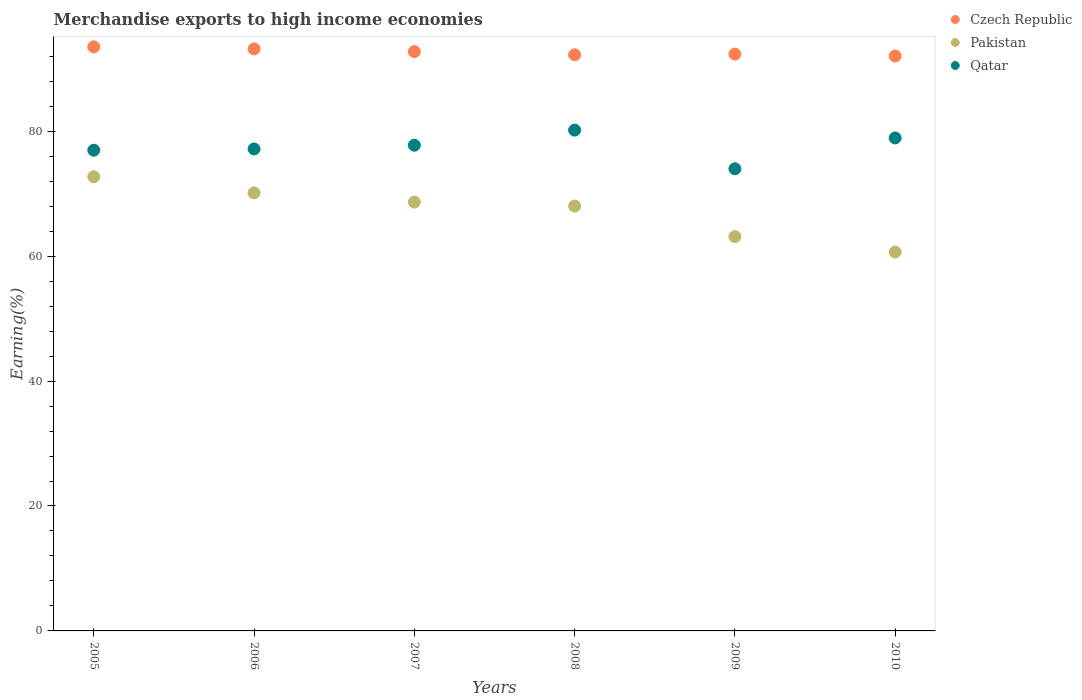Is the number of dotlines equal to the number of legend labels?
Offer a terse response. Yes. What is the percentage of amount earned from merchandise exports in Qatar in 2009?
Make the answer very short. 73.98. Across all years, what is the maximum percentage of amount earned from merchandise exports in Pakistan?
Your answer should be very brief. 72.71. Across all years, what is the minimum percentage of amount earned from merchandise exports in Czech Republic?
Provide a short and direct response. 92.03. What is the total percentage of amount earned from merchandise exports in Pakistan in the graph?
Provide a succinct answer. 403.28. What is the difference between the percentage of amount earned from merchandise exports in Pakistan in 2008 and that in 2009?
Make the answer very short. 4.9. What is the difference between the percentage of amount earned from merchandise exports in Czech Republic in 2009 and the percentage of amount earned from merchandise exports in Pakistan in 2008?
Keep it short and to the point. 24.32. What is the average percentage of amount earned from merchandise exports in Czech Republic per year?
Your answer should be very brief. 92.67. In the year 2005, what is the difference between the percentage of amount earned from merchandise exports in Qatar and percentage of amount earned from merchandise exports in Pakistan?
Offer a very short reply. 4.25. What is the ratio of the percentage of amount earned from merchandise exports in Pakistan in 2005 to that in 2010?
Ensure brevity in your answer.  1.2. What is the difference between the highest and the second highest percentage of amount earned from merchandise exports in Pakistan?
Give a very brief answer. 2.58. What is the difference between the highest and the lowest percentage of amount earned from merchandise exports in Pakistan?
Your response must be concise. 12.05. Is the percentage of amount earned from merchandise exports in Czech Republic strictly greater than the percentage of amount earned from merchandise exports in Qatar over the years?
Your answer should be compact. Yes. Is the percentage of amount earned from merchandise exports in Czech Republic strictly less than the percentage of amount earned from merchandise exports in Qatar over the years?
Keep it short and to the point. No. How many years are there in the graph?
Offer a very short reply. 6. Are the values on the major ticks of Y-axis written in scientific E-notation?
Your answer should be compact. No. How many legend labels are there?
Offer a very short reply. 3. What is the title of the graph?
Make the answer very short. Merchandise exports to high income economies. What is the label or title of the Y-axis?
Keep it short and to the point. Earning(%). What is the Earning(%) of Czech Republic in 2005?
Give a very brief answer. 93.51. What is the Earning(%) of Pakistan in 2005?
Offer a very short reply. 72.71. What is the Earning(%) in Qatar in 2005?
Offer a terse response. 76.96. What is the Earning(%) in Czech Republic in 2006?
Offer a terse response. 93.18. What is the Earning(%) of Pakistan in 2006?
Provide a succinct answer. 70.13. What is the Earning(%) of Qatar in 2006?
Provide a short and direct response. 77.16. What is the Earning(%) of Czech Republic in 2007?
Provide a succinct answer. 92.75. What is the Earning(%) of Pakistan in 2007?
Your answer should be compact. 68.65. What is the Earning(%) of Qatar in 2007?
Provide a succinct answer. 77.75. What is the Earning(%) of Czech Republic in 2008?
Your response must be concise. 92.23. What is the Earning(%) of Pakistan in 2008?
Provide a succinct answer. 68.02. What is the Earning(%) of Qatar in 2008?
Offer a very short reply. 80.17. What is the Earning(%) in Czech Republic in 2009?
Give a very brief answer. 92.34. What is the Earning(%) of Pakistan in 2009?
Give a very brief answer. 63.12. What is the Earning(%) in Qatar in 2009?
Make the answer very short. 73.98. What is the Earning(%) of Czech Republic in 2010?
Offer a very short reply. 92.03. What is the Earning(%) in Pakistan in 2010?
Make the answer very short. 60.66. What is the Earning(%) in Qatar in 2010?
Your answer should be very brief. 78.92. Across all years, what is the maximum Earning(%) in Czech Republic?
Your response must be concise. 93.51. Across all years, what is the maximum Earning(%) in Pakistan?
Offer a terse response. 72.71. Across all years, what is the maximum Earning(%) of Qatar?
Your answer should be compact. 80.17. Across all years, what is the minimum Earning(%) in Czech Republic?
Make the answer very short. 92.03. Across all years, what is the minimum Earning(%) of Pakistan?
Provide a short and direct response. 60.66. Across all years, what is the minimum Earning(%) of Qatar?
Provide a short and direct response. 73.98. What is the total Earning(%) in Czech Republic in the graph?
Give a very brief answer. 556.04. What is the total Earning(%) of Pakistan in the graph?
Your response must be concise. 403.28. What is the total Earning(%) in Qatar in the graph?
Make the answer very short. 464.95. What is the difference between the Earning(%) of Czech Republic in 2005 and that in 2006?
Your answer should be very brief. 0.33. What is the difference between the Earning(%) in Pakistan in 2005 and that in 2006?
Your response must be concise. 2.58. What is the difference between the Earning(%) of Qatar in 2005 and that in 2006?
Offer a very short reply. -0.2. What is the difference between the Earning(%) of Czech Republic in 2005 and that in 2007?
Make the answer very short. 0.76. What is the difference between the Earning(%) in Pakistan in 2005 and that in 2007?
Keep it short and to the point. 4.06. What is the difference between the Earning(%) of Qatar in 2005 and that in 2007?
Offer a very short reply. -0.8. What is the difference between the Earning(%) of Czech Republic in 2005 and that in 2008?
Offer a terse response. 1.27. What is the difference between the Earning(%) in Pakistan in 2005 and that in 2008?
Offer a very short reply. 4.69. What is the difference between the Earning(%) in Qatar in 2005 and that in 2008?
Your answer should be very brief. -3.22. What is the difference between the Earning(%) of Czech Republic in 2005 and that in 2009?
Provide a short and direct response. 1.17. What is the difference between the Earning(%) of Pakistan in 2005 and that in 2009?
Your response must be concise. 9.59. What is the difference between the Earning(%) in Qatar in 2005 and that in 2009?
Your answer should be very brief. 2.97. What is the difference between the Earning(%) of Czech Republic in 2005 and that in 2010?
Your answer should be compact. 1.48. What is the difference between the Earning(%) in Pakistan in 2005 and that in 2010?
Offer a terse response. 12.05. What is the difference between the Earning(%) in Qatar in 2005 and that in 2010?
Provide a succinct answer. -1.96. What is the difference between the Earning(%) in Czech Republic in 2006 and that in 2007?
Offer a terse response. 0.43. What is the difference between the Earning(%) in Pakistan in 2006 and that in 2007?
Provide a short and direct response. 1.48. What is the difference between the Earning(%) in Qatar in 2006 and that in 2007?
Ensure brevity in your answer.  -0.6. What is the difference between the Earning(%) in Czech Republic in 2006 and that in 2008?
Make the answer very short. 0.95. What is the difference between the Earning(%) in Pakistan in 2006 and that in 2008?
Make the answer very short. 2.11. What is the difference between the Earning(%) of Qatar in 2006 and that in 2008?
Give a very brief answer. -3.02. What is the difference between the Earning(%) of Czech Republic in 2006 and that in 2009?
Provide a succinct answer. 0.84. What is the difference between the Earning(%) in Pakistan in 2006 and that in 2009?
Keep it short and to the point. 7.01. What is the difference between the Earning(%) of Qatar in 2006 and that in 2009?
Give a very brief answer. 3.17. What is the difference between the Earning(%) in Czech Republic in 2006 and that in 2010?
Your response must be concise. 1.15. What is the difference between the Earning(%) of Pakistan in 2006 and that in 2010?
Make the answer very short. 9.47. What is the difference between the Earning(%) of Qatar in 2006 and that in 2010?
Offer a terse response. -1.76. What is the difference between the Earning(%) of Czech Republic in 2007 and that in 2008?
Provide a succinct answer. 0.51. What is the difference between the Earning(%) of Pakistan in 2007 and that in 2008?
Give a very brief answer. 0.63. What is the difference between the Earning(%) of Qatar in 2007 and that in 2008?
Give a very brief answer. -2.42. What is the difference between the Earning(%) of Czech Republic in 2007 and that in 2009?
Give a very brief answer. 0.4. What is the difference between the Earning(%) in Pakistan in 2007 and that in 2009?
Your answer should be very brief. 5.53. What is the difference between the Earning(%) of Qatar in 2007 and that in 2009?
Your response must be concise. 3.77. What is the difference between the Earning(%) of Czech Republic in 2007 and that in 2010?
Offer a very short reply. 0.71. What is the difference between the Earning(%) in Pakistan in 2007 and that in 2010?
Ensure brevity in your answer.  7.99. What is the difference between the Earning(%) in Qatar in 2007 and that in 2010?
Your response must be concise. -1.17. What is the difference between the Earning(%) in Czech Republic in 2008 and that in 2009?
Provide a short and direct response. -0.11. What is the difference between the Earning(%) in Pakistan in 2008 and that in 2009?
Provide a short and direct response. 4.9. What is the difference between the Earning(%) in Qatar in 2008 and that in 2009?
Provide a short and direct response. 6.19. What is the difference between the Earning(%) in Czech Republic in 2008 and that in 2010?
Ensure brevity in your answer.  0.2. What is the difference between the Earning(%) of Pakistan in 2008 and that in 2010?
Offer a terse response. 7.36. What is the difference between the Earning(%) in Qatar in 2008 and that in 2010?
Provide a succinct answer. 1.25. What is the difference between the Earning(%) of Czech Republic in 2009 and that in 2010?
Make the answer very short. 0.31. What is the difference between the Earning(%) in Pakistan in 2009 and that in 2010?
Provide a short and direct response. 2.47. What is the difference between the Earning(%) in Qatar in 2009 and that in 2010?
Give a very brief answer. -4.94. What is the difference between the Earning(%) of Czech Republic in 2005 and the Earning(%) of Pakistan in 2006?
Offer a very short reply. 23.38. What is the difference between the Earning(%) in Czech Republic in 2005 and the Earning(%) in Qatar in 2006?
Provide a succinct answer. 16.35. What is the difference between the Earning(%) in Pakistan in 2005 and the Earning(%) in Qatar in 2006?
Provide a succinct answer. -4.45. What is the difference between the Earning(%) in Czech Republic in 2005 and the Earning(%) in Pakistan in 2007?
Ensure brevity in your answer.  24.86. What is the difference between the Earning(%) in Czech Republic in 2005 and the Earning(%) in Qatar in 2007?
Ensure brevity in your answer.  15.75. What is the difference between the Earning(%) of Pakistan in 2005 and the Earning(%) of Qatar in 2007?
Your answer should be very brief. -5.04. What is the difference between the Earning(%) of Czech Republic in 2005 and the Earning(%) of Pakistan in 2008?
Your answer should be very brief. 25.49. What is the difference between the Earning(%) of Czech Republic in 2005 and the Earning(%) of Qatar in 2008?
Offer a very short reply. 13.33. What is the difference between the Earning(%) in Pakistan in 2005 and the Earning(%) in Qatar in 2008?
Provide a succinct answer. -7.46. What is the difference between the Earning(%) in Czech Republic in 2005 and the Earning(%) in Pakistan in 2009?
Your answer should be compact. 30.39. What is the difference between the Earning(%) in Czech Republic in 2005 and the Earning(%) in Qatar in 2009?
Your answer should be compact. 19.52. What is the difference between the Earning(%) in Pakistan in 2005 and the Earning(%) in Qatar in 2009?
Your answer should be compact. -1.27. What is the difference between the Earning(%) of Czech Republic in 2005 and the Earning(%) of Pakistan in 2010?
Ensure brevity in your answer.  32.85. What is the difference between the Earning(%) of Czech Republic in 2005 and the Earning(%) of Qatar in 2010?
Your answer should be compact. 14.59. What is the difference between the Earning(%) of Pakistan in 2005 and the Earning(%) of Qatar in 2010?
Keep it short and to the point. -6.21. What is the difference between the Earning(%) in Czech Republic in 2006 and the Earning(%) in Pakistan in 2007?
Your response must be concise. 24.53. What is the difference between the Earning(%) of Czech Republic in 2006 and the Earning(%) of Qatar in 2007?
Offer a very short reply. 15.43. What is the difference between the Earning(%) in Pakistan in 2006 and the Earning(%) in Qatar in 2007?
Your answer should be very brief. -7.63. What is the difference between the Earning(%) in Czech Republic in 2006 and the Earning(%) in Pakistan in 2008?
Your answer should be very brief. 25.16. What is the difference between the Earning(%) in Czech Republic in 2006 and the Earning(%) in Qatar in 2008?
Provide a succinct answer. 13.01. What is the difference between the Earning(%) of Pakistan in 2006 and the Earning(%) of Qatar in 2008?
Give a very brief answer. -10.05. What is the difference between the Earning(%) in Czech Republic in 2006 and the Earning(%) in Pakistan in 2009?
Your response must be concise. 30.06. What is the difference between the Earning(%) in Czech Republic in 2006 and the Earning(%) in Qatar in 2009?
Offer a very short reply. 19.19. What is the difference between the Earning(%) in Pakistan in 2006 and the Earning(%) in Qatar in 2009?
Give a very brief answer. -3.86. What is the difference between the Earning(%) in Czech Republic in 2006 and the Earning(%) in Pakistan in 2010?
Provide a succinct answer. 32.52. What is the difference between the Earning(%) in Czech Republic in 2006 and the Earning(%) in Qatar in 2010?
Ensure brevity in your answer.  14.26. What is the difference between the Earning(%) of Pakistan in 2006 and the Earning(%) of Qatar in 2010?
Provide a short and direct response. -8.79. What is the difference between the Earning(%) in Czech Republic in 2007 and the Earning(%) in Pakistan in 2008?
Keep it short and to the point. 24.73. What is the difference between the Earning(%) in Czech Republic in 2007 and the Earning(%) in Qatar in 2008?
Make the answer very short. 12.57. What is the difference between the Earning(%) in Pakistan in 2007 and the Earning(%) in Qatar in 2008?
Your answer should be compact. -11.53. What is the difference between the Earning(%) in Czech Republic in 2007 and the Earning(%) in Pakistan in 2009?
Provide a short and direct response. 29.62. What is the difference between the Earning(%) in Czech Republic in 2007 and the Earning(%) in Qatar in 2009?
Make the answer very short. 18.76. What is the difference between the Earning(%) in Pakistan in 2007 and the Earning(%) in Qatar in 2009?
Offer a very short reply. -5.34. What is the difference between the Earning(%) of Czech Republic in 2007 and the Earning(%) of Pakistan in 2010?
Offer a very short reply. 32.09. What is the difference between the Earning(%) of Czech Republic in 2007 and the Earning(%) of Qatar in 2010?
Offer a very short reply. 13.82. What is the difference between the Earning(%) in Pakistan in 2007 and the Earning(%) in Qatar in 2010?
Your response must be concise. -10.27. What is the difference between the Earning(%) of Czech Republic in 2008 and the Earning(%) of Pakistan in 2009?
Offer a terse response. 29.11. What is the difference between the Earning(%) in Czech Republic in 2008 and the Earning(%) in Qatar in 2009?
Your answer should be compact. 18.25. What is the difference between the Earning(%) of Pakistan in 2008 and the Earning(%) of Qatar in 2009?
Your answer should be very brief. -5.97. What is the difference between the Earning(%) in Czech Republic in 2008 and the Earning(%) in Pakistan in 2010?
Your response must be concise. 31.58. What is the difference between the Earning(%) of Czech Republic in 2008 and the Earning(%) of Qatar in 2010?
Provide a short and direct response. 13.31. What is the difference between the Earning(%) in Pakistan in 2008 and the Earning(%) in Qatar in 2010?
Give a very brief answer. -10.9. What is the difference between the Earning(%) in Czech Republic in 2009 and the Earning(%) in Pakistan in 2010?
Provide a short and direct response. 31.69. What is the difference between the Earning(%) in Czech Republic in 2009 and the Earning(%) in Qatar in 2010?
Ensure brevity in your answer.  13.42. What is the difference between the Earning(%) in Pakistan in 2009 and the Earning(%) in Qatar in 2010?
Provide a succinct answer. -15.8. What is the average Earning(%) of Czech Republic per year?
Give a very brief answer. 92.67. What is the average Earning(%) of Pakistan per year?
Provide a short and direct response. 67.21. What is the average Earning(%) of Qatar per year?
Provide a succinct answer. 77.49. In the year 2005, what is the difference between the Earning(%) in Czech Republic and Earning(%) in Pakistan?
Ensure brevity in your answer.  20.8. In the year 2005, what is the difference between the Earning(%) in Czech Republic and Earning(%) in Qatar?
Offer a terse response. 16.55. In the year 2005, what is the difference between the Earning(%) in Pakistan and Earning(%) in Qatar?
Offer a very short reply. -4.25. In the year 2006, what is the difference between the Earning(%) in Czech Republic and Earning(%) in Pakistan?
Keep it short and to the point. 23.05. In the year 2006, what is the difference between the Earning(%) of Czech Republic and Earning(%) of Qatar?
Your answer should be very brief. 16.02. In the year 2006, what is the difference between the Earning(%) in Pakistan and Earning(%) in Qatar?
Your answer should be very brief. -7.03. In the year 2007, what is the difference between the Earning(%) in Czech Republic and Earning(%) in Pakistan?
Your answer should be compact. 24.1. In the year 2007, what is the difference between the Earning(%) of Czech Republic and Earning(%) of Qatar?
Provide a short and direct response. 14.99. In the year 2007, what is the difference between the Earning(%) of Pakistan and Earning(%) of Qatar?
Your response must be concise. -9.11. In the year 2008, what is the difference between the Earning(%) of Czech Republic and Earning(%) of Pakistan?
Your answer should be very brief. 24.22. In the year 2008, what is the difference between the Earning(%) in Czech Republic and Earning(%) in Qatar?
Provide a succinct answer. 12.06. In the year 2008, what is the difference between the Earning(%) in Pakistan and Earning(%) in Qatar?
Ensure brevity in your answer.  -12.16. In the year 2009, what is the difference between the Earning(%) of Czech Republic and Earning(%) of Pakistan?
Your answer should be compact. 29.22. In the year 2009, what is the difference between the Earning(%) of Czech Republic and Earning(%) of Qatar?
Offer a terse response. 18.36. In the year 2009, what is the difference between the Earning(%) in Pakistan and Earning(%) in Qatar?
Ensure brevity in your answer.  -10.86. In the year 2010, what is the difference between the Earning(%) in Czech Republic and Earning(%) in Pakistan?
Provide a succinct answer. 31.38. In the year 2010, what is the difference between the Earning(%) in Czech Republic and Earning(%) in Qatar?
Make the answer very short. 13.11. In the year 2010, what is the difference between the Earning(%) of Pakistan and Earning(%) of Qatar?
Keep it short and to the point. -18.27. What is the ratio of the Earning(%) in Pakistan in 2005 to that in 2006?
Offer a terse response. 1.04. What is the ratio of the Earning(%) of Qatar in 2005 to that in 2006?
Offer a very short reply. 1. What is the ratio of the Earning(%) of Czech Republic in 2005 to that in 2007?
Provide a succinct answer. 1.01. What is the ratio of the Earning(%) in Pakistan in 2005 to that in 2007?
Offer a very short reply. 1.06. What is the ratio of the Earning(%) of Qatar in 2005 to that in 2007?
Offer a very short reply. 0.99. What is the ratio of the Earning(%) of Czech Republic in 2005 to that in 2008?
Your answer should be very brief. 1.01. What is the ratio of the Earning(%) in Pakistan in 2005 to that in 2008?
Provide a succinct answer. 1.07. What is the ratio of the Earning(%) in Qatar in 2005 to that in 2008?
Offer a terse response. 0.96. What is the ratio of the Earning(%) in Czech Republic in 2005 to that in 2009?
Your answer should be compact. 1.01. What is the ratio of the Earning(%) in Pakistan in 2005 to that in 2009?
Your answer should be compact. 1.15. What is the ratio of the Earning(%) of Qatar in 2005 to that in 2009?
Offer a terse response. 1.04. What is the ratio of the Earning(%) of Pakistan in 2005 to that in 2010?
Provide a short and direct response. 1.2. What is the ratio of the Earning(%) in Qatar in 2005 to that in 2010?
Your response must be concise. 0.98. What is the ratio of the Earning(%) in Czech Republic in 2006 to that in 2007?
Your answer should be very brief. 1. What is the ratio of the Earning(%) of Pakistan in 2006 to that in 2007?
Offer a very short reply. 1.02. What is the ratio of the Earning(%) of Qatar in 2006 to that in 2007?
Keep it short and to the point. 0.99. What is the ratio of the Earning(%) of Czech Republic in 2006 to that in 2008?
Your answer should be compact. 1.01. What is the ratio of the Earning(%) in Pakistan in 2006 to that in 2008?
Your answer should be very brief. 1.03. What is the ratio of the Earning(%) of Qatar in 2006 to that in 2008?
Your answer should be compact. 0.96. What is the ratio of the Earning(%) of Czech Republic in 2006 to that in 2009?
Your answer should be very brief. 1.01. What is the ratio of the Earning(%) of Pakistan in 2006 to that in 2009?
Provide a short and direct response. 1.11. What is the ratio of the Earning(%) of Qatar in 2006 to that in 2009?
Make the answer very short. 1.04. What is the ratio of the Earning(%) of Czech Republic in 2006 to that in 2010?
Provide a short and direct response. 1.01. What is the ratio of the Earning(%) in Pakistan in 2006 to that in 2010?
Give a very brief answer. 1.16. What is the ratio of the Earning(%) of Qatar in 2006 to that in 2010?
Provide a short and direct response. 0.98. What is the ratio of the Earning(%) of Pakistan in 2007 to that in 2008?
Offer a very short reply. 1.01. What is the ratio of the Earning(%) of Qatar in 2007 to that in 2008?
Make the answer very short. 0.97. What is the ratio of the Earning(%) in Czech Republic in 2007 to that in 2009?
Ensure brevity in your answer.  1. What is the ratio of the Earning(%) in Pakistan in 2007 to that in 2009?
Keep it short and to the point. 1.09. What is the ratio of the Earning(%) in Qatar in 2007 to that in 2009?
Your answer should be compact. 1.05. What is the ratio of the Earning(%) in Czech Republic in 2007 to that in 2010?
Provide a succinct answer. 1.01. What is the ratio of the Earning(%) in Pakistan in 2007 to that in 2010?
Ensure brevity in your answer.  1.13. What is the ratio of the Earning(%) of Qatar in 2007 to that in 2010?
Offer a terse response. 0.99. What is the ratio of the Earning(%) in Pakistan in 2008 to that in 2009?
Your response must be concise. 1.08. What is the ratio of the Earning(%) of Qatar in 2008 to that in 2009?
Offer a terse response. 1.08. What is the ratio of the Earning(%) of Czech Republic in 2008 to that in 2010?
Provide a succinct answer. 1. What is the ratio of the Earning(%) in Pakistan in 2008 to that in 2010?
Give a very brief answer. 1.12. What is the ratio of the Earning(%) of Qatar in 2008 to that in 2010?
Your answer should be very brief. 1.02. What is the ratio of the Earning(%) of Czech Republic in 2009 to that in 2010?
Your answer should be very brief. 1. What is the ratio of the Earning(%) of Pakistan in 2009 to that in 2010?
Make the answer very short. 1.04. What is the ratio of the Earning(%) in Qatar in 2009 to that in 2010?
Provide a short and direct response. 0.94. What is the difference between the highest and the second highest Earning(%) of Czech Republic?
Ensure brevity in your answer.  0.33. What is the difference between the highest and the second highest Earning(%) in Pakistan?
Ensure brevity in your answer.  2.58. What is the difference between the highest and the second highest Earning(%) of Qatar?
Offer a terse response. 1.25. What is the difference between the highest and the lowest Earning(%) in Czech Republic?
Ensure brevity in your answer.  1.48. What is the difference between the highest and the lowest Earning(%) of Pakistan?
Provide a succinct answer. 12.05. What is the difference between the highest and the lowest Earning(%) of Qatar?
Your response must be concise. 6.19. 